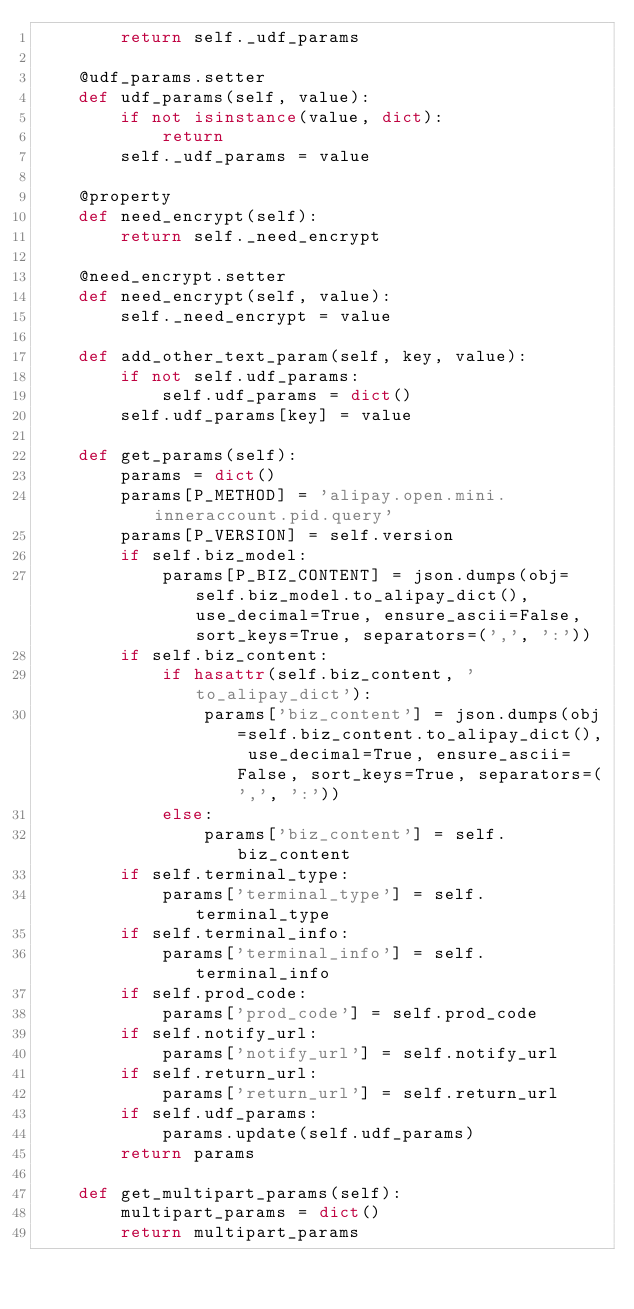<code> <loc_0><loc_0><loc_500><loc_500><_Python_>        return self._udf_params

    @udf_params.setter
    def udf_params(self, value):
        if not isinstance(value, dict):
            return
        self._udf_params = value

    @property
    def need_encrypt(self):
        return self._need_encrypt

    @need_encrypt.setter
    def need_encrypt(self, value):
        self._need_encrypt = value

    def add_other_text_param(self, key, value):
        if not self.udf_params:
            self.udf_params = dict()
        self.udf_params[key] = value

    def get_params(self):
        params = dict()
        params[P_METHOD] = 'alipay.open.mini.inneraccount.pid.query'
        params[P_VERSION] = self.version
        if self.biz_model:
            params[P_BIZ_CONTENT] = json.dumps(obj=self.biz_model.to_alipay_dict(), use_decimal=True, ensure_ascii=False, sort_keys=True, separators=(',', ':'))
        if self.biz_content:
            if hasattr(self.biz_content, 'to_alipay_dict'):
                params['biz_content'] = json.dumps(obj=self.biz_content.to_alipay_dict(), use_decimal=True, ensure_ascii=False, sort_keys=True, separators=(',', ':'))
            else:
                params['biz_content'] = self.biz_content
        if self.terminal_type:
            params['terminal_type'] = self.terminal_type
        if self.terminal_info:
            params['terminal_info'] = self.terminal_info
        if self.prod_code:
            params['prod_code'] = self.prod_code
        if self.notify_url:
            params['notify_url'] = self.notify_url
        if self.return_url:
            params['return_url'] = self.return_url
        if self.udf_params:
            params.update(self.udf_params)
        return params

    def get_multipart_params(self):
        multipart_params = dict()
        return multipart_params
</code> 